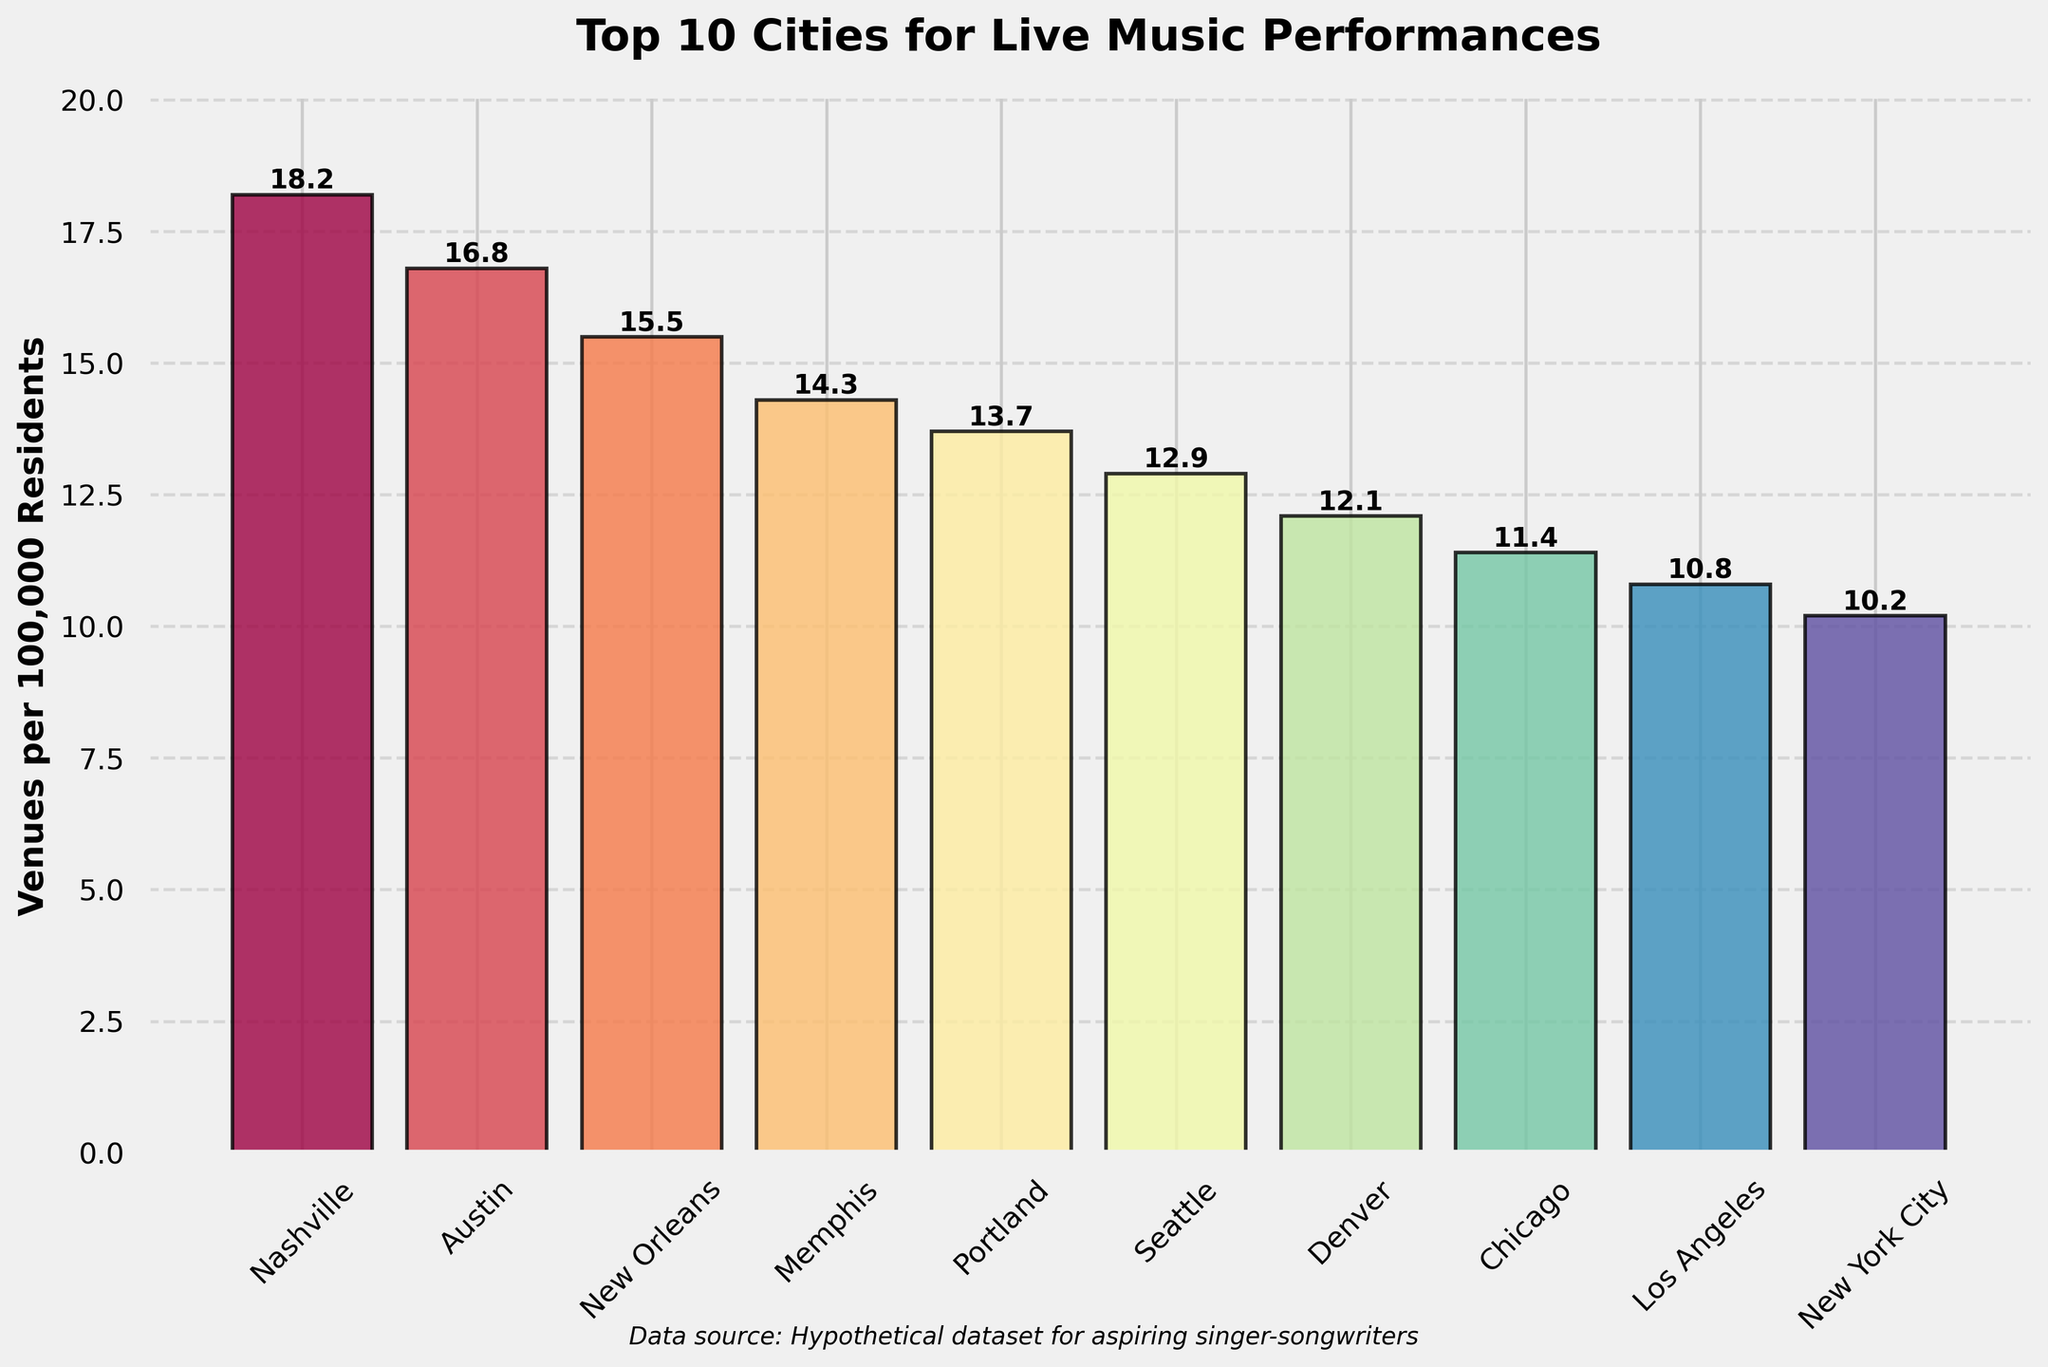How many more venues per 100k residents does Nashville have compared to New York City? To find this, we subtract the number of venues per 100k residents in New York City (10.2) from the number in Nashville (18.2). The difference is 18.2 - 10.2 = 8.0.
Answer: 8.0 Which city has the fewest live music venues per 100k residents? By examining the heights of the bars and the corresponding labels, we see that New York City has the shortest bar with 10.2 venues per 100k residents.
Answer: New York City Is the average number of venues per 100k residents for the top three cities greater than 15? We calculate the average for Nashville (18.2), Austin (16.8), and New Orleans (15.5). The sum is 18.2 + 16.8 + 15.5 = 50.5, and the average is 50.5 / 3 ≈ 16.83, which is greater than 15.
Answer: Yes Which city between Denver and Portland has more live music venues per 100k residents, and by how much? Portland has 13.7 venues while Denver has 12.1. Portland has more venues, and the difference is 13.7 - 12.1 = 1.6 venues.
Answer: Portland, 1.6 What is the total number of live music venues per 100k residents for all cities combined? Summing up all the values: 18.2 + 16.8 + 15.5 + 14.3 + 13.7 + 12.9 + 12.1 + 11.4 + 10.8 + 10.2 = 135.9.
Answer: 135.9 Are there more or fewer venues per 100k residents in Seattle compared to Los Angeles? By comparing the heights of the bars, Seattle has 12.9 venues per 100k residents while Los Angeles has 10.8. Seattle has more.
Answer: More Between Chicago and Memphis, which city has a greater rate of live music venues per 100k residents, and by how much? Memphis has 14.3 venues, while Chicago has 11.4. Memphis has more, with a difference of 14.3 - 11.4 = 2.9.
Answer: Memphis, 2.9 What's the median value of venues per 100k residents among the top 10 cities? Sorting the values: 10.2, 10.8, 11.4, 12.1, 12.9, 13.7, 14.3, 15.5, 16.8, 18.2. The median value is the average of the 5th and 6th values: (12.9 + 13.7) / 2 = 13.3.
Answer: 13.3 Which city has a visually distinct color among the top 10, according to the color spectrum used in the bar plot? The bar plot uses the Spectral colormap, where each bar has a unique shade. Chicago, noticeably in a prominent shade between blue and purple, stands out.
Answer: Chicago 